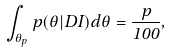Convert formula to latex. <formula><loc_0><loc_0><loc_500><loc_500>\int _ { \theta _ { p } } p ( \theta | D I ) d \theta = \frac { p } { 1 0 0 } ,</formula> 